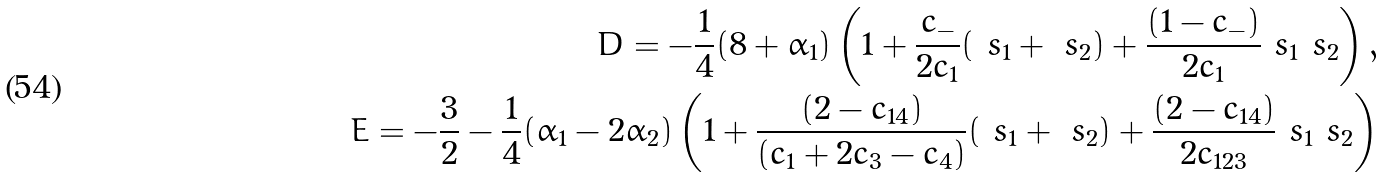Convert formula to latex. <formula><loc_0><loc_0><loc_500><loc_500>D = - \frac { 1 } { 4 } ( 8 + \alpha _ { 1 } ) \left ( 1 + \frac { c _ { - } } { 2 c _ { 1 } } ( \ s _ { 1 } + \ s _ { 2 } ) + \frac { ( 1 - c _ { - } ) } { 2 c _ { 1 } } \ s _ { 1 } \ s _ { 2 } \right ) , \\ E = - \frac { 3 } { 2 } - \frac { 1 } { 4 } ( \alpha _ { 1 } - 2 \alpha _ { 2 } ) \left ( 1 + \frac { ( 2 - c _ { 1 4 } ) } { ( c _ { 1 } + 2 c _ { 3 } - c _ { 4 } ) } ( \ s _ { 1 } + \ s _ { 2 } ) + \frac { ( 2 - c _ { 1 4 } ) } { 2 c _ { 1 2 3 } } \ s _ { 1 } \ s _ { 2 } \right )</formula> 